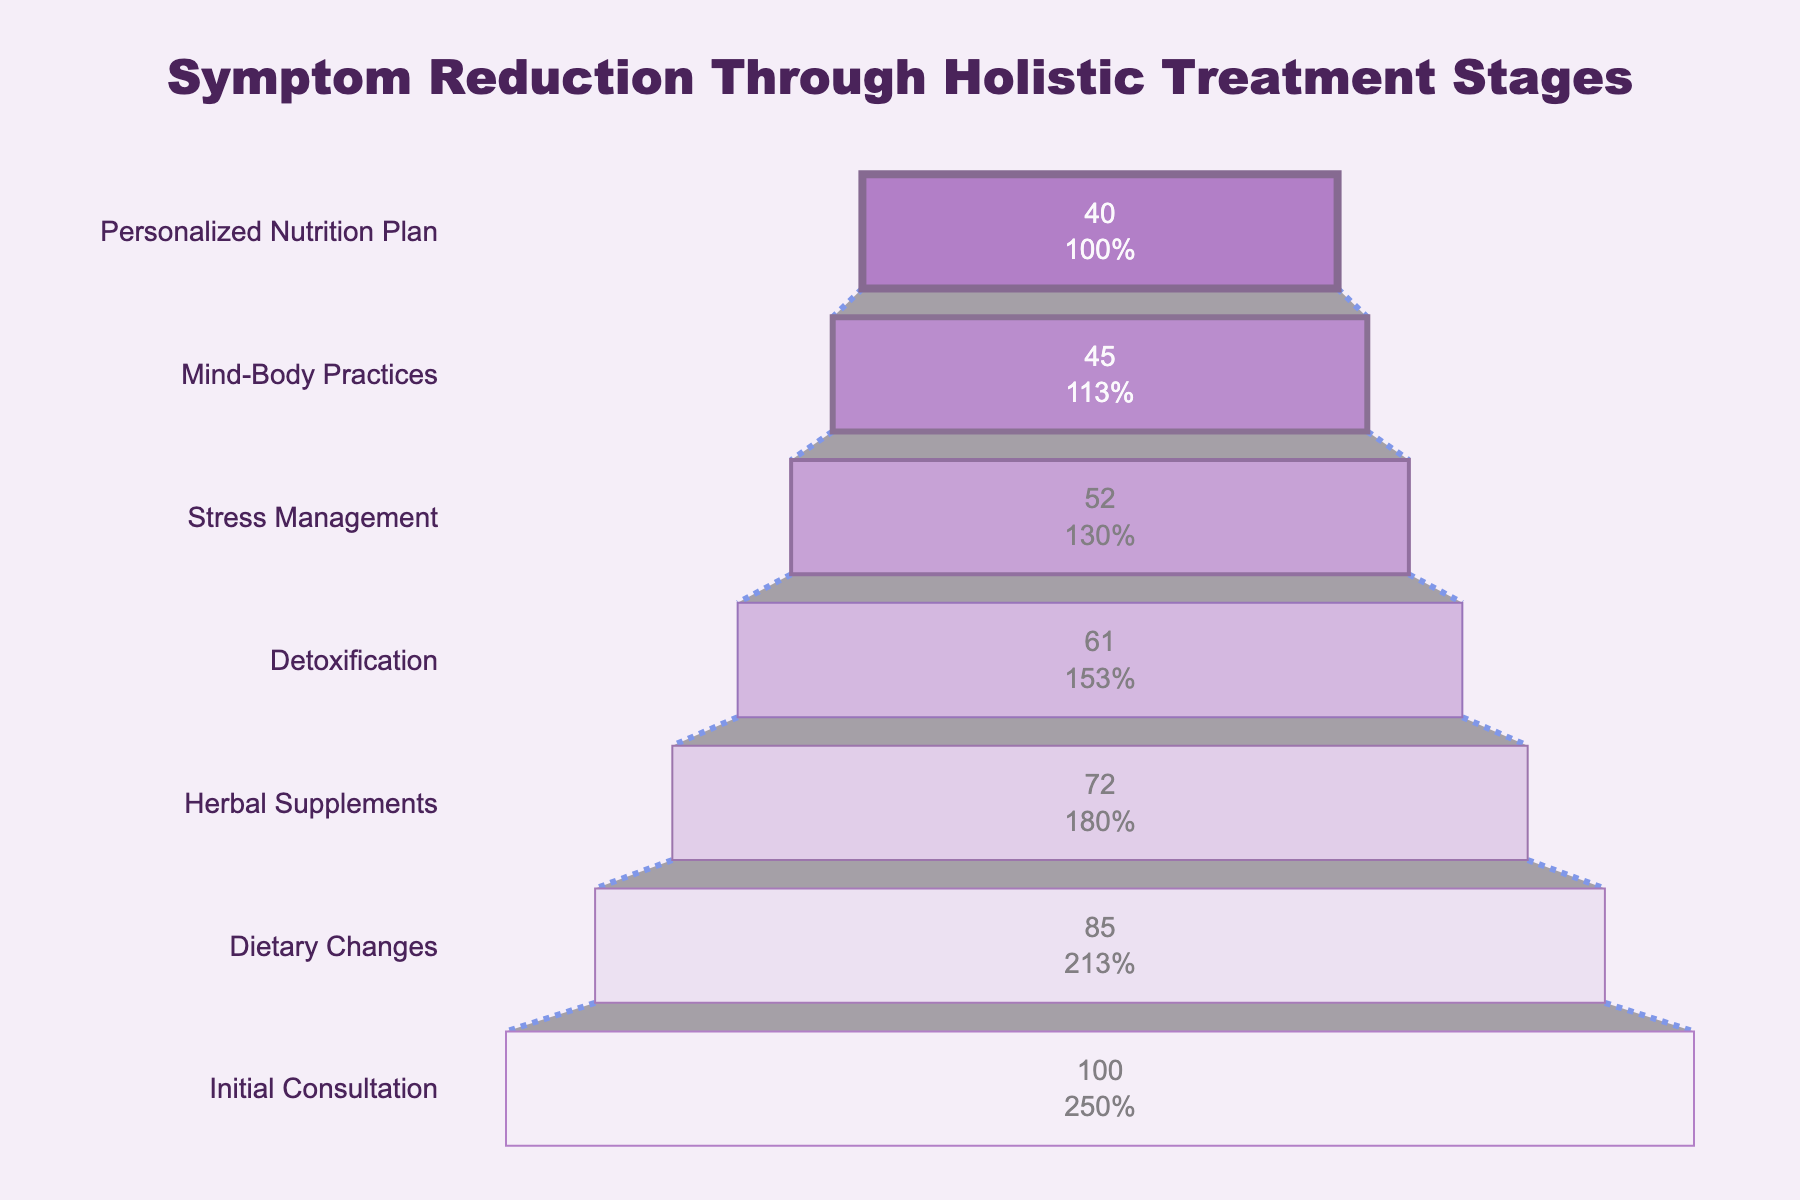What's the title of the chart? The title of the chart is at the top. It reads, "Symptom Reduction Through Holistic Treatment Stages".
Answer: Symptom Reduction Through Holistic Treatment Stages How many treatment stages are shown in the chart? The chart lists out all the stages on the y-axis. Counting these, we find there are seven stages.
Answer: Seven Which stage reports the highest number of clients with symptom reduction? The first segment from the top, labeled "Initial Consultation", has the highest value (100 clients).
Answer: Initial Consultation What percent of initial clients report symptom reduction at the Dietary Changes stage? There are 100 clients initially, and at the Dietary Changes stage, 85 clients report a reduction. 85/100 = 85%.
Answer: 85% How many clients report symptom reduction after going through the Stress Management stage? Referring to the "Stress Management" segment in the chart, we see it has a value of 52 clients.
Answer: 52 What's the difference in the number of clients between the Detoxification and Herbal Supplements stages? The chart shows 61 clients for Detoxification and 72 clients for Herbal Supplements. The difference is 72 - 61 = 11 clients.
Answer: 11 At which stage do the number of clients experiencing symptom reduction drop below half of the initial number? The initial number is 100. Half of 100 is 50. The stage where the number drops below 50 is the "Mind-Body Practices" stage with 45 clients.
Answer: Mind-Body Practices Which stage has the smallest reduction in clients compared to the previous stage? By examining the differences between each successive pair: 
Initial to Dietary (100-85)=15, Dietary to Herbal (85-72)=13, Herbal to Detox (72-61)=11, Detox to Stress (61-52)=9, Stress to Mind-Body (52-45)=7, Mind-Body to Personalized (45-40)=5. The smallest reduction is between the "Mind-Body Practices" and "Personalized Nutrition Plan" stages, which is 5 clients.
Answer: Mind-Body Practices to Personalized Nutrition Plan What is the total number of clients reporting symptom reduction after the Detoxification stage? The number of clients reporting reduction at the Detoxification stage is explicitly shown in the chart as 61 clients.
Answer: 61 Which stages show more than a 10% drop in clients from the previous stage? To find this manually:
- Initial (100) to Dietary (85): (100-85)/100 = 15%
- Dietary (85) to Herbal (72): (85-72)/85 ≈ 15.29%
- Herbal (72) to Detox (61): (72-61)/72 ≈ 15.28%
- Detox (61) to Stress (52): (61-52)/61 ≈ 14.75%
- Stress (52) to Mind-Body (45): (52-45)/52 ≈ 13.46%
- Mind-Body (45) to Personalized (40): (45-40)/45 ≈ 11.11% 
All stages except the transition from Mind-Body Practices to Personalized Nutrition Plan show more than a 10% drop.
Answer: All except Mind-Body Practices to Personalized Nutrition Plan 